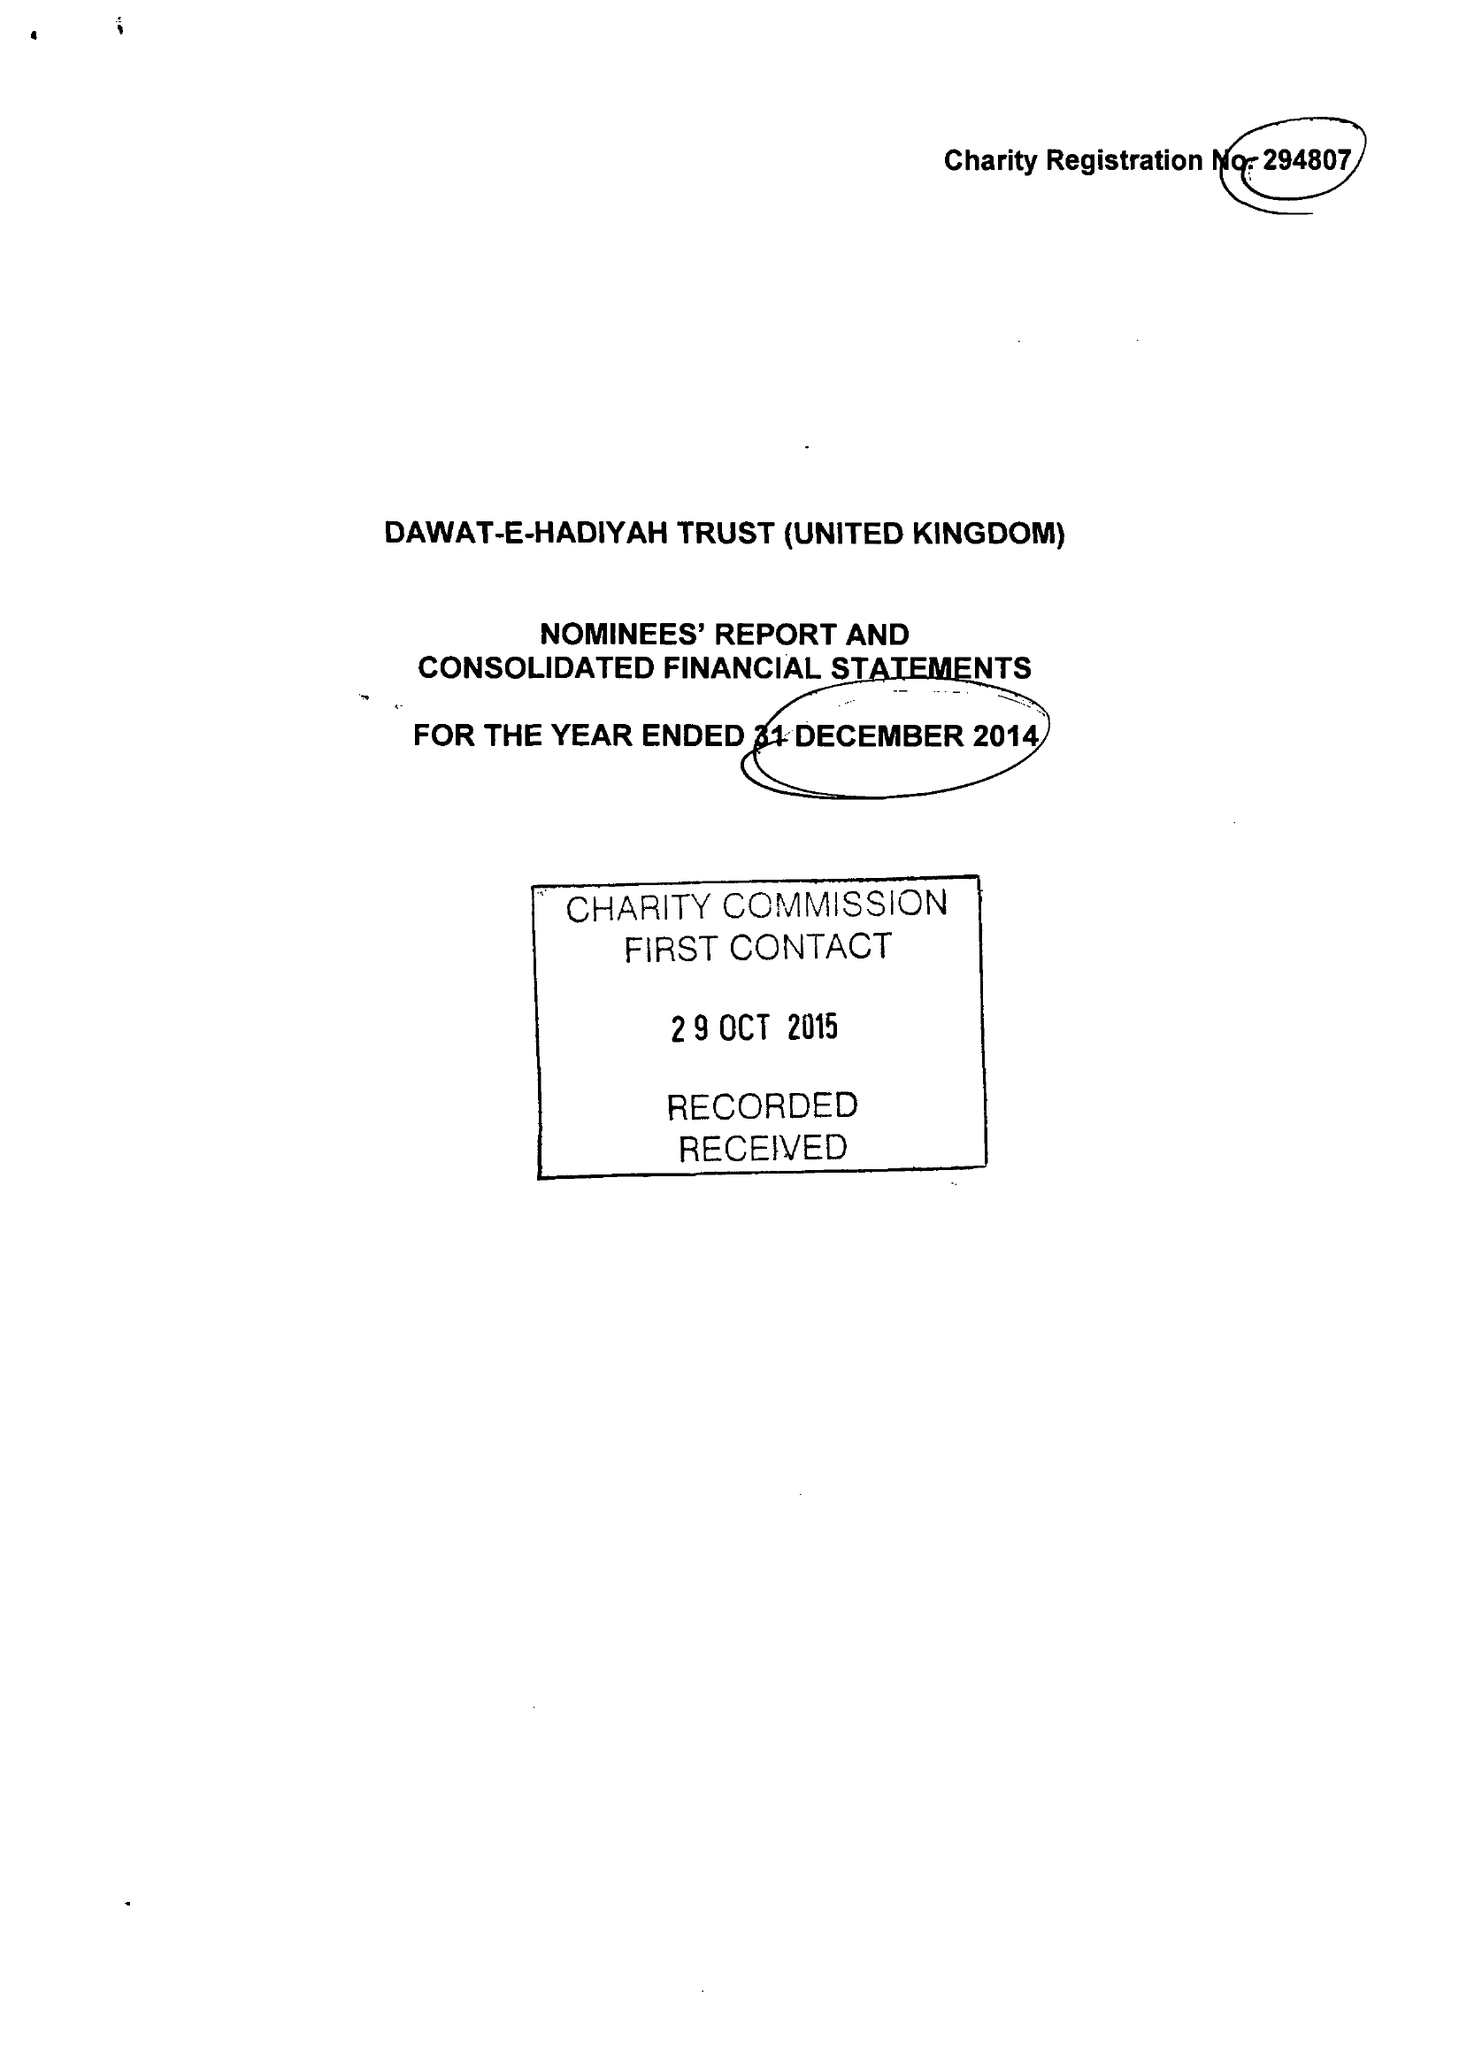What is the value for the address__street_line?
Answer the question using a single word or phrase. ROWDELL ROAD 